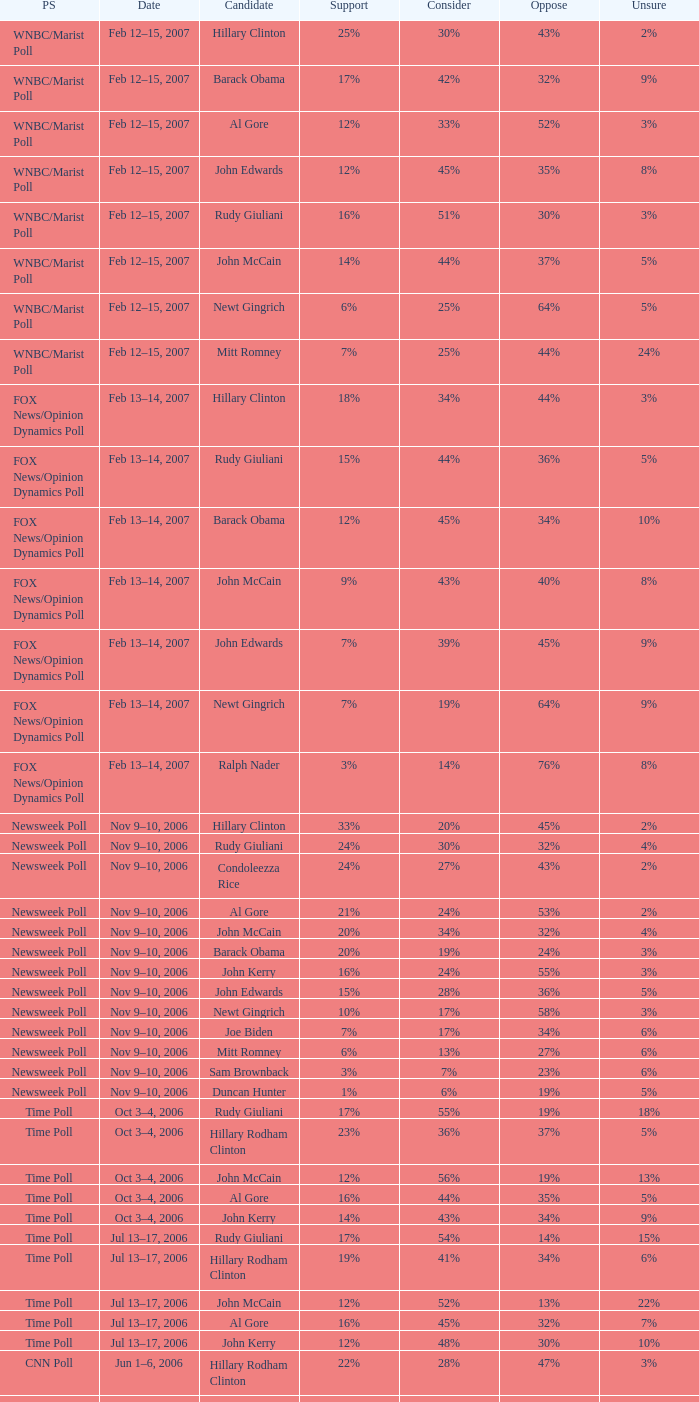What percentage of people said they would consider Rudy Giuliani as a candidate according to the Newsweek poll that showed 32% opposed him? 30%. 